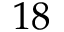Convert formula to latex. <formula><loc_0><loc_0><loc_500><loc_500>1 8</formula> 